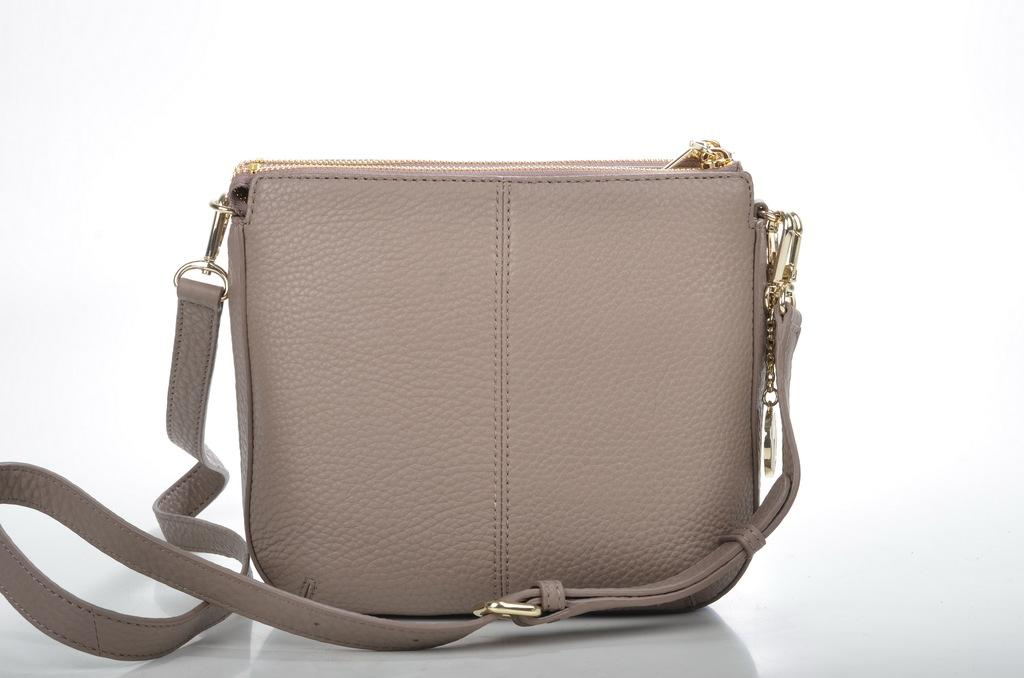What type of accessory is present in the image? There is a handbag in the image. What feature does the handbag have? The handbag has a zip. Is there any other accessory attached to the handbag? Yes, there is a belt attached to the handbag. What type of drink is being served in the handbag in the image? There is no drink, such as eggnog, present in the handbag or the image. What rule is being enforced by the donkey in the image? There is no donkey present in the image, and therefore no rule being enforced. 